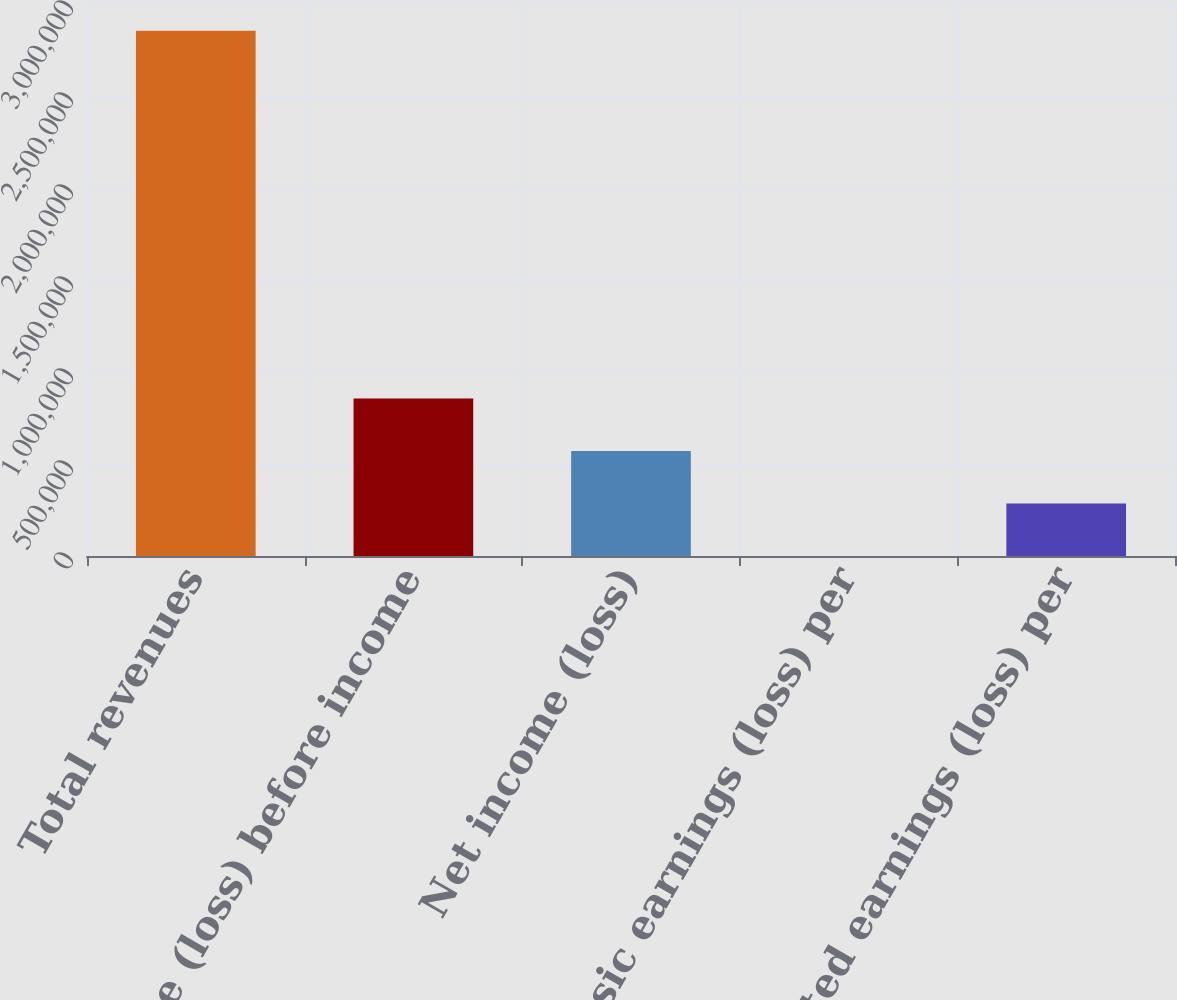Convert chart to OTSL. <chart><loc_0><loc_0><loc_500><loc_500><bar_chart><fcel>Total revenues<fcel>Income (loss) before income<fcel>Net income (loss)<fcel>Basic earnings (loss) per<fcel>Diluted earnings (loss) per<nl><fcel>2.85503e+06<fcel>856510<fcel>571006<fcel>0.01<fcel>285503<nl></chart> 